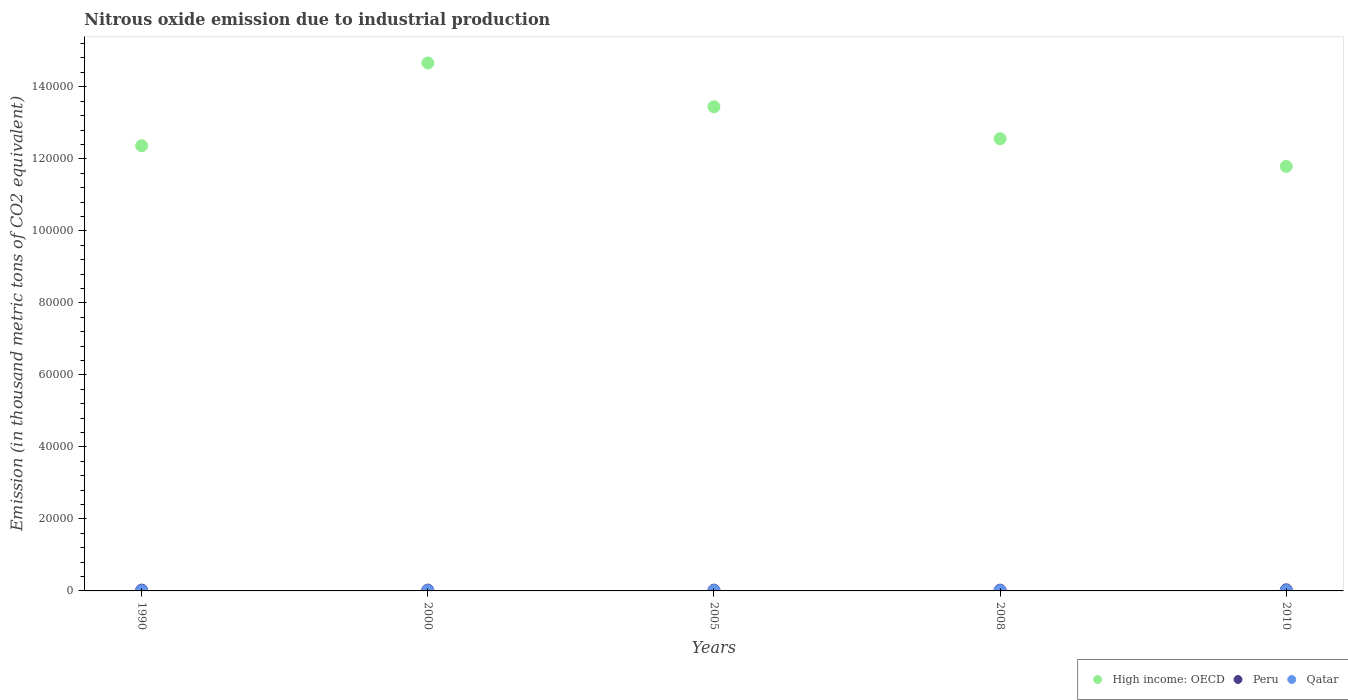What is the amount of nitrous oxide emitted in High income: OECD in 2010?
Your answer should be compact. 1.18e+05. Across all years, what is the maximum amount of nitrous oxide emitted in High income: OECD?
Make the answer very short. 1.47e+05. Across all years, what is the minimum amount of nitrous oxide emitted in Qatar?
Ensure brevity in your answer.  30.8. In which year was the amount of nitrous oxide emitted in High income: OECD maximum?
Provide a short and direct response. 2000. In which year was the amount of nitrous oxide emitted in Peru minimum?
Your answer should be very brief. 2008. What is the total amount of nitrous oxide emitted in Qatar in the graph?
Offer a very short reply. 353.6. What is the difference between the amount of nitrous oxide emitted in High income: OECD in 2005 and that in 2008?
Keep it short and to the point. 8873.1. What is the difference between the amount of nitrous oxide emitted in Qatar in 2000 and the amount of nitrous oxide emitted in Peru in 2010?
Provide a succinct answer. -234.9. What is the average amount of nitrous oxide emitted in Qatar per year?
Give a very brief answer. 70.72. In the year 2000, what is the difference between the amount of nitrous oxide emitted in Peru and amount of nitrous oxide emitted in High income: OECD?
Ensure brevity in your answer.  -1.46e+05. What is the ratio of the amount of nitrous oxide emitted in High income: OECD in 1990 to that in 2008?
Offer a terse response. 0.98. Is the amount of nitrous oxide emitted in High income: OECD in 2000 less than that in 2008?
Your response must be concise. No. What is the difference between the highest and the second highest amount of nitrous oxide emitted in Qatar?
Ensure brevity in your answer.  12.7. What is the difference between the highest and the lowest amount of nitrous oxide emitted in High income: OECD?
Provide a short and direct response. 2.87e+04. Is it the case that in every year, the sum of the amount of nitrous oxide emitted in Qatar and amount of nitrous oxide emitted in Peru  is greater than the amount of nitrous oxide emitted in High income: OECD?
Offer a very short reply. No. Does the amount of nitrous oxide emitted in High income: OECD monotonically increase over the years?
Your response must be concise. No. Is the amount of nitrous oxide emitted in Peru strictly greater than the amount of nitrous oxide emitted in High income: OECD over the years?
Give a very brief answer. No. Is the amount of nitrous oxide emitted in Peru strictly less than the amount of nitrous oxide emitted in High income: OECD over the years?
Provide a short and direct response. Yes. How many years are there in the graph?
Keep it short and to the point. 5. How are the legend labels stacked?
Your response must be concise. Horizontal. What is the title of the graph?
Offer a very short reply. Nitrous oxide emission due to industrial production. What is the label or title of the Y-axis?
Your answer should be compact. Emission (in thousand metric tons of CO2 equivalent). What is the Emission (in thousand metric tons of CO2 equivalent) of High income: OECD in 1990?
Provide a short and direct response. 1.24e+05. What is the Emission (in thousand metric tons of CO2 equivalent) of Peru in 1990?
Make the answer very short. 227.9. What is the Emission (in thousand metric tons of CO2 equivalent) of Qatar in 1990?
Your answer should be compact. 30.8. What is the Emission (in thousand metric tons of CO2 equivalent) in High income: OECD in 2000?
Provide a short and direct response. 1.47e+05. What is the Emission (in thousand metric tons of CO2 equivalent) in Peru in 2000?
Make the answer very short. 235.2. What is the Emission (in thousand metric tons of CO2 equivalent) of Qatar in 2000?
Your answer should be very brief. 69.5. What is the Emission (in thousand metric tons of CO2 equivalent) in High income: OECD in 2005?
Provide a short and direct response. 1.34e+05. What is the Emission (in thousand metric tons of CO2 equivalent) in Peru in 2005?
Offer a very short reply. 217.8. What is the Emission (in thousand metric tons of CO2 equivalent) in Qatar in 2005?
Your answer should be compact. 78.2. What is the Emission (in thousand metric tons of CO2 equivalent) in High income: OECD in 2008?
Your answer should be compact. 1.26e+05. What is the Emission (in thousand metric tons of CO2 equivalent) of Peru in 2008?
Ensure brevity in your answer.  214.1. What is the Emission (in thousand metric tons of CO2 equivalent) of Qatar in 2008?
Ensure brevity in your answer.  81.2. What is the Emission (in thousand metric tons of CO2 equivalent) of High income: OECD in 2010?
Give a very brief answer. 1.18e+05. What is the Emission (in thousand metric tons of CO2 equivalent) of Peru in 2010?
Keep it short and to the point. 304.4. What is the Emission (in thousand metric tons of CO2 equivalent) in Qatar in 2010?
Ensure brevity in your answer.  93.9. Across all years, what is the maximum Emission (in thousand metric tons of CO2 equivalent) in High income: OECD?
Offer a very short reply. 1.47e+05. Across all years, what is the maximum Emission (in thousand metric tons of CO2 equivalent) of Peru?
Make the answer very short. 304.4. Across all years, what is the maximum Emission (in thousand metric tons of CO2 equivalent) in Qatar?
Give a very brief answer. 93.9. Across all years, what is the minimum Emission (in thousand metric tons of CO2 equivalent) in High income: OECD?
Make the answer very short. 1.18e+05. Across all years, what is the minimum Emission (in thousand metric tons of CO2 equivalent) of Peru?
Offer a very short reply. 214.1. Across all years, what is the minimum Emission (in thousand metric tons of CO2 equivalent) of Qatar?
Your answer should be very brief. 30.8. What is the total Emission (in thousand metric tons of CO2 equivalent) in High income: OECD in the graph?
Your answer should be very brief. 6.48e+05. What is the total Emission (in thousand metric tons of CO2 equivalent) of Peru in the graph?
Offer a very short reply. 1199.4. What is the total Emission (in thousand metric tons of CO2 equivalent) in Qatar in the graph?
Provide a succinct answer. 353.6. What is the difference between the Emission (in thousand metric tons of CO2 equivalent) in High income: OECD in 1990 and that in 2000?
Your answer should be compact. -2.30e+04. What is the difference between the Emission (in thousand metric tons of CO2 equivalent) of Peru in 1990 and that in 2000?
Provide a succinct answer. -7.3. What is the difference between the Emission (in thousand metric tons of CO2 equivalent) in Qatar in 1990 and that in 2000?
Your response must be concise. -38.7. What is the difference between the Emission (in thousand metric tons of CO2 equivalent) in High income: OECD in 1990 and that in 2005?
Your response must be concise. -1.08e+04. What is the difference between the Emission (in thousand metric tons of CO2 equivalent) in Qatar in 1990 and that in 2005?
Make the answer very short. -47.4. What is the difference between the Emission (in thousand metric tons of CO2 equivalent) in High income: OECD in 1990 and that in 2008?
Your answer should be very brief. -1956.6. What is the difference between the Emission (in thousand metric tons of CO2 equivalent) in Qatar in 1990 and that in 2008?
Offer a terse response. -50.4. What is the difference between the Emission (in thousand metric tons of CO2 equivalent) in High income: OECD in 1990 and that in 2010?
Offer a very short reply. 5738. What is the difference between the Emission (in thousand metric tons of CO2 equivalent) of Peru in 1990 and that in 2010?
Provide a short and direct response. -76.5. What is the difference between the Emission (in thousand metric tons of CO2 equivalent) of Qatar in 1990 and that in 2010?
Keep it short and to the point. -63.1. What is the difference between the Emission (in thousand metric tons of CO2 equivalent) of High income: OECD in 2000 and that in 2005?
Provide a succinct answer. 1.22e+04. What is the difference between the Emission (in thousand metric tons of CO2 equivalent) of Qatar in 2000 and that in 2005?
Keep it short and to the point. -8.7. What is the difference between the Emission (in thousand metric tons of CO2 equivalent) in High income: OECD in 2000 and that in 2008?
Provide a succinct answer. 2.10e+04. What is the difference between the Emission (in thousand metric tons of CO2 equivalent) in Peru in 2000 and that in 2008?
Give a very brief answer. 21.1. What is the difference between the Emission (in thousand metric tons of CO2 equivalent) of Qatar in 2000 and that in 2008?
Keep it short and to the point. -11.7. What is the difference between the Emission (in thousand metric tons of CO2 equivalent) in High income: OECD in 2000 and that in 2010?
Provide a succinct answer. 2.87e+04. What is the difference between the Emission (in thousand metric tons of CO2 equivalent) of Peru in 2000 and that in 2010?
Provide a short and direct response. -69.2. What is the difference between the Emission (in thousand metric tons of CO2 equivalent) in Qatar in 2000 and that in 2010?
Offer a very short reply. -24.4. What is the difference between the Emission (in thousand metric tons of CO2 equivalent) of High income: OECD in 2005 and that in 2008?
Ensure brevity in your answer.  8873.1. What is the difference between the Emission (in thousand metric tons of CO2 equivalent) of Peru in 2005 and that in 2008?
Ensure brevity in your answer.  3.7. What is the difference between the Emission (in thousand metric tons of CO2 equivalent) of Qatar in 2005 and that in 2008?
Your response must be concise. -3. What is the difference between the Emission (in thousand metric tons of CO2 equivalent) of High income: OECD in 2005 and that in 2010?
Provide a short and direct response. 1.66e+04. What is the difference between the Emission (in thousand metric tons of CO2 equivalent) of Peru in 2005 and that in 2010?
Your answer should be compact. -86.6. What is the difference between the Emission (in thousand metric tons of CO2 equivalent) of Qatar in 2005 and that in 2010?
Give a very brief answer. -15.7. What is the difference between the Emission (in thousand metric tons of CO2 equivalent) in High income: OECD in 2008 and that in 2010?
Keep it short and to the point. 7694.6. What is the difference between the Emission (in thousand metric tons of CO2 equivalent) in Peru in 2008 and that in 2010?
Keep it short and to the point. -90.3. What is the difference between the Emission (in thousand metric tons of CO2 equivalent) of Qatar in 2008 and that in 2010?
Your response must be concise. -12.7. What is the difference between the Emission (in thousand metric tons of CO2 equivalent) of High income: OECD in 1990 and the Emission (in thousand metric tons of CO2 equivalent) of Peru in 2000?
Provide a short and direct response. 1.23e+05. What is the difference between the Emission (in thousand metric tons of CO2 equivalent) in High income: OECD in 1990 and the Emission (in thousand metric tons of CO2 equivalent) in Qatar in 2000?
Keep it short and to the point. 1.24e+05. What is the difference between the Emission (in thousand metric tons of CO2 equivalent) of Peru in 1990 and the Emission (in thousand metric tons of CO2 equivalent) of Qatar in 2000?
Offer a very short reply. 158.4. What is the difference between the Emission (in thousand metric tons of CO2 equivalent) of High income: OECD in 1990 and the Emission (in thousand metric tons of CO2 equivalent) of Peru in 2005?
Provide a succinct answer. 1.23e+05. What is the difference between the Emission (in thousand metric tons of CO2 equivalent) in High income: OECD in 1990 and the Emission (in thousand metric tons of CO2 equivalent) in Qatar in 2005?
Provide a succinct answer. 1.24e+05. What is the difference between the Emission (in thousand metric tons of CO2 equivalent) in Peru in 1990 and the Emission (in thousand metric tons of CO2 equivalent) in Qatar in 2005?
Ensure brevity in your answer.  149.7. What is the difference between the Emission (in thousand metric tons of CO2 equivalent) of High income: OECD in 1990 and the Emission (in thousand metric tons of CO2 equivalent) of Peru in 2008?
Your response must be concise. 1.23e+05. What is the difference between the Emission (in thousand metric tons of CO2 equivalent) in High income: OECD in 1990 and the Emission (in thousand metric tons of CO2 equivalent) in Qatar in 2008?
Offer a very short reply. 1.24e+05. What is the difference between the Emission (in thousand metric tons of CO2 equivalent) in Peru in 1990 and the Emission (in thousand metric tons of CO2 equivalent) in Qatar in 2008?
Give a very brief answer. 146.7. What is the difference between the Emission (in thousand metric tons of CO2 equivalent) in High income: OECD in 1990 and the Emission (in thousand metric tons of CO2 equivalent) in Peru in 2010?
Make the answer very short. 1.23e+05. What is the difference between the Emission (in thousand metric tons of CO2 equivalent) in High income: OECD in 1990 and the Emission (in thousand metric tons of CO2 equivalent) in Qatar in 2010?
Provide a short and direct response. 1.24e+05. What is the difference between the Emission (in thousand metric tons of CO2 equivalent) of Peru in 1990 and the Emission (in thousand metric tons of CO2 equivalent) of Qatar in 2010?
Give a very brief answer. 134. What is the difference between the Emission (in thousand metric tons of CO2 equivalent) in High income: OECD in 2000 and the Emission (in thousand metric tons of CO2 equivalent) in Peru in 2005?
Offer a terse response. 1.46e+05. What is the difference between the Emission (in thousand metric tons of CO2 equivalent) of High income: OECD in 2000 and the Emission (in thousand metric tons of CO2 equivalent) of Qatar in 2005?
Provide a short and direct response. 1.47e+05. What is the difference between the Emission (in thousand metric tons of CO2 equivalent) in Peru in 2000 and the Emission (in thousand metric tons of CO2 equivalent) in Qatar in 2005?
Offer a terse response. 157. What is the difference between the Emission (in thousand metric tons of CO2 equivalent) of High income: OECD in 2000 and the Emission (in thousand metric tons of CO2 equivalent) of Peru in 2008?
Ensure brevity in your answer.  1.46e+05. What is the difference between the Emission (in thousand metric tons of CO2 equivalent) of High income: OECD in 2000 and the Emission (in thousand metric tons of CO2 equivalent) of Qatar in 2008?
Keep it short and to the point. 1.47e+05. What is the difference between the Emission (in thousand metric tons of CO2 equivalent) in Peru in 2000 and the Emission (in thousand metric tons of CO2 equivalent) in Qatar in 2008?
Your answer should be compact. 154. What is the difference between the Emission (in thousand metric tons of CO2 equivalent) in High income: OECD in 2000 and the Emission (in thousand metric tons of CO2 equivalent) in Peru in 2010?
Provide a short and direct response. 1.46e+05. What is the difference between the Emission (in thousand metric tons of CO2 equivalent) in High income: OECD in 2000 and the Emission (in thousand metric tons of CO2 equivalent) in Qatar in 2010?
Offer a terse response. 1.47e+05. What is the difference between the Emission (in thousand metric tons of CO2 equivalent) in Peru in 2000 and the Emission (in thousand metric tons of CO2 equivalent) in Qatar in 2010?
Make the answer very short. 141.3. What is the difference between the Emission (in thousand metric tons of CO2 equivalent) in High income: OECD in 2005 and the Emission (in thousand metric tons of CO2 equivalent) in Peru in 2008?
Make the answer very short. 1.34e+05. What is the difference between the Emission (in thousand metric tons of CO2 equivalent) of High income: OECD in 2005 and the Emission (in thousand metric tons of CO2 equivalent) of Qatar in 2008?
Offer a terse response. 1.34e+05. What is the difference between the Emission (in thousand metric tons of CO2 equivalent) in Peru in 2005 and the Emission (in thousand metric tons of CO2 equivalent) in Qatar in 2008?
Offer a very short reply. 136.6. What is the difference between the Emission (in thousand metric tons of CO2 equivalent) in High income: OECD in 2005 and the Emission (in thousand metric tons of CO2 equivalent) in Peru in 2010?
Your answer should be very brief. 1.34e+05. What is the difference between the Emission (in thousand metric tons of CO2 equivalent) in High income: OECD in 2005 and the Emission (in thousand metric tons of CO2 equivalent) in Qatar in 2010?
Provide a short and direct response. 1.34e+05. What is the difference between the Emission (in thousand metric tons of CO2 equivalent) in Peru in 2005 and the Emission (in thousand metric tons of CO2 equivalent) in Qatar in 2010?
Ensure brevity in your answer.  123.9. What is the difference between the Emission (in thousand metric tons of CO2 equivalent) in High income: OECD in 2008 and the Emission (in thousand metric tons of CO2 equivalent) in Peru in 2010?
Give a very brief answer. 1.25e+05. What is the difference between the Emission (in thousand metric tons of CO2 equivalent) of High income: OECD in 2008 and the Emission (in thousand metric tons of CO2 equivalent) of Qatar in 2010?
Offer a very short reply. 1.25e+05. What is the difference between the Emission (in thousand metric tons of CO2 equivalent) of Peru in 2008 and the Emission (in thousand metric tons of CO2 equivalent) of Qatar in 2010?
Keep it short and to the point. 120.2. What is the average Emission (in thousand metric tons of CO2 equivalent) of High income: OECD per year?
Your answer should be compact. 1.30e+05. What is the average Emission (in thousand metric tons of CO2 equivalent) in Peru per year?
Your answer should be very brief. 239.88. What is the average Emission (in thousand metric tons of CO2 equivalent) in Qatar per year?
Offer a very short reply. 70.72. In the year 1990, what is the difference between the Emission (in thousand metric tons of CO2 equivalent) of High income: OECD and Emission (in thousand metric tons of CO2 equivalent) of Peru?
Your answer should be very brief. 1.23e+05. In the year 1990, what is the difference between the Emission (in thousand metric tons of CO2 equivalent) of High income: OECD and Emission (in thousand metric tons of CO2 equivalent) of Qatar?
Give a very brief answer. 1.24e+05. In the year 1990, what is the difference between the Emission (in thousand metric tons of CO2 equivalent) of Peru and Emission (in thousand metric tons of CO2 equivalent) of Qatar?
Ensure brevity in your answer.  197.1. In the year 2000, what is the difference between the Emission (in thousand metric tons of CO2 equivalent) in High income: OECD and Emission (in thousand metric tons of CO2 equivalent) in Peru?
Your answer should be very brief. 1.46e+05. In the year 2000, what is the difference between the Emission (in thousand metric tons of CO2 equivalent) in High income: OECD and Emission (in thousand metric tons of CO2 equivalent) in Qatar?
Offer a terse response. 1.47e+05. In the year 2000, what is the difference between the Emission (in thousand metric tons of CO2 equivalent) of Peru and Emission (in thousand metric tons of CO2 equivalent) of Qatar?
Keep it short and to the point. 165.7. In the year 2005, what is the difference between the Emission (in thousand metric tons of CO2 equivalent) in High income: OECD and Emission (in thousand metric tons of CO2 equivalent) in Peru?
Your answer should be very brief. 1.34e+05. In the year 2005, what is the difference between the Emission (in thousand metric tons of CO2 equivalent) of High income: OECD and Emission (in thousand metric tons of CO2 equivalent) of Qatar?
Keep it short and to the point. 1.34e+05. In the year 2005, what is the difference between the Emission (in thousand metric tons of CO2 equivalent) of Peru and Emission (in thousand metric tons of CO2 equivalent) of Qatar?
Your answer should be very brief. 139.6. In the year 2008, what is the difference between the Emission (in thousand metric tons of CO2 equivalent) in High income: OECD and Emission (in thousand metric tons of CO2 equivalent) in Peru?
Keep it short and to the point. 1.25e+05. In the year 2008, what is the difference between the Emission (in thousand metric tons of CO2 equivalent) of High income: OECD and Emission (in thousand metric tons of CO2 equivalent) of Qatar?
Your answer should be compact. 1.26e+05. In the year 2008, what is the difference between the Emission (in thousand metric tons of CO2 equivalent) of Peru and Emission (in thousand metric tons of CO2 equivalent) of Qatar?
Provide a short and direct response. 132.9. In the year 2010, what is the difference between the Emission (in thousand metric tons of CO2 equivalent) in High income: OECD and Emission (in thousand metric tons of CO2 equivalent) in Peru?
Ensure brevity in your answer.  1.18e+05. In the year 2010, what is the difference between the Emission (in thousand metric tons of CO2 equivalent) of High income: OECD and Emission (in thousand metric tons of CO2 equivalent) of Qatar?
Make the answer very short. 1.18e+05. In the year 2010, what is the difference between the Emission (in thousand metric tons of CO2 equivalent) in Peru and Emission (in thousand metric tons of CO2 equivalent) in Qatar?
Offer a very short reply. 210.5. What is the ratio of the Emission (in thousand metric tons of CO2 equivalent) in High income: OECD in 1990 to that in 2000?
Make the answer very short. 0.84. What is the ratio of the Emission (in thousand metric tons of CO2 equivalent) of Peru in 1990 to that in 2000?
Ensure brevity in your answer.  0.97. What is the ratio of the Emission (in thousand metric tons of CO2 equivalent) in Qatar in 1990 to that in 2000?
Provide a short and direct response. 0.44. What is the ratio of the Emission (in thousand metric tons of CO2 equivalent) of High income: OECD in 1990 to that in 2005?
Keep it short and to the point. 0.92. What is the ratio of the Emission (in thousand metric tons of CO2 equivalent) in Peru in 1990 to that in 2005?
Your answer should be compact. 1.05. What is the ratio of the Emission (in thousand metric tons of CO2 equivalent) of Qatar in 1990 to that in 2005?
Provide a short and direct response. 0.39. What is the ratio of the Emission (in thousand metric tons of CO2 equivalent) in High income: OECD in 1990 to that in 2008?
Keep it short and to the point. 0.98. What is the ratio of the Emission (in thousand metric tons of CO2 equivalent) of Peru in 1990 to that in 2008?
Give a very brief answer. 1.06. What is the ratio of the Emission (in thousand metric tons of CO2 equivalent) of Qatar in 1990 to that in 2008?
Make the answer very short. 0.38. What is the ratio of the Emission (in thousand metric tons of CO2 equivalent) in High income: OECD in 1990 to that in 2010?
Give a very brief answer. 1.05. What is the ratio of the Emission (in thousand metric tons of CO2 equivalent) in Peru in 1990 to that in 2010?
Your answer should be compact. 0.75. What is the ratio of the Emission (in thousand metric tons of CO2 equivalent) of Qatar in 1990 to that in 2010?
Your answer should be compact. 0.33. What is the ratio of the Emission (in thousand metric tons of CO2 equivalent) in High income: OECD in 2000 to that in 2005?
Provide a succinct answer. 1.09. What is the ratio of the Emission (in thousand metric tons of CO2 equivalent) in Peru in 2000 to that in 2005?
Your answer should be very brief. 1.08. What is the ratio of the Emission (in thousand metric tons of CO2 equivalent) in Qatar in 2000 to that in 2005?
Offer a very short reply. 0.89. What is the ratio of the Emission (in thousand metric tons of CO2 equivalent) in High income: OECD in 2000 to that in 2008?
Keep it short and to the point. 1.17. What is the ratio of the Emission (in thousand metric tons of CO2 equivalent) in Peru in 2000 to that in 2008?
Provide a succinct answer. 1.1. What is the ratio of the Emission (in thousand metric tons of CO2 equivalent) in Qatar in 2000 to that in 2008?
Keep it short and to the point. 0.86. What is the ratio of the Emission (in thousand metric tons of CO2 equivalent) of High income: OECD in 2000 to that in 2010?
Keep it short and to the point. 1.24. What is the ratio of the Emission (in thousand metric tons of CO2 equivalent) of Peru in 2000 to that in 2010?
Offer a terse response. 0.77. What is the ratio of the Emission (in thousand metric tons of CO2 equivalent) in Qatar in 2000 to that in 2010?
Your answer should be very brief. 0.74. What is the ratio of the Emission (in thousand metric tons of CO2 equivalent) in High income: OECD in 2005 to that in 2008?
Provide a succinct answer. 1.07. What is the ratio of the Emission (in thousand metric tons of CO2 equivalent) of Peru in 2005 to that in 2008?
Provide a succinct answer. 1.02. What is the ratio of the Emission (in thousand metric tons of CO2 equivalent) in Qatar in 2005 to that in 2008?
Provide a short and direct response. 0.96. What is the ratio of the Emission (in thousand metric tons of CO2 equivalent) in High income: OECD in 2005 to that in 2010?
Offer a terse response. 1.14. What is the ratio of the Emission (in thousand metric tons of CO2 equivalent) of Peru in 2005 to that in 2010?
Keep it short and to the point. 0.72. What is the ratio of the Emission (in thousand metric tons of CO2 equivalent) in Qatar in 2005 to that in 2010?
Offer a very short reply. 0.83. What is the ratio of the Emission (in thousand metric tons of CO2 equivalent) in High income: OECD in 2008 to that in 2010?
Offer a very short reply. 1.07. What is the ratio of the Emission (in thousand metric tons of CO2 equivalent) in Peru in 2008 to that in 2010?
Give a very brief answer. 0.7. What is the ratio of the Emission (in thousand metric tons of CO2 equivalent) in Qatar in 2008 to that in 2010?
Ensure brevity in your answer.  0.86. What is the difference between the highest and the second highest Emission (in thousand metric tons of CO2 equivalent) in High income: OECD?
Provide a succinct answer. 1.22e+04. What is the difference between the highest and the second highest Emission (in thousand metric tons of CO2 equivalent) in Peru?
Your answer should be very brief. 69.2. What is the difference between the highest and the lowest Emission (in thousand metric tons of CO2 equivalent) in High income: OECD?
Provide a short and direct response. 2.87e+04. What is the difference between the highest and the lowest Emission (in thousand metric tons of CO2 equivalent) in Peru?
Your answer should be compact. 90.3. What is the difference between the highest and the lowest Emission (in thousand metric tons of CO2 equivalent) of Qatar?
Provide a short and direct response. 63.1. 